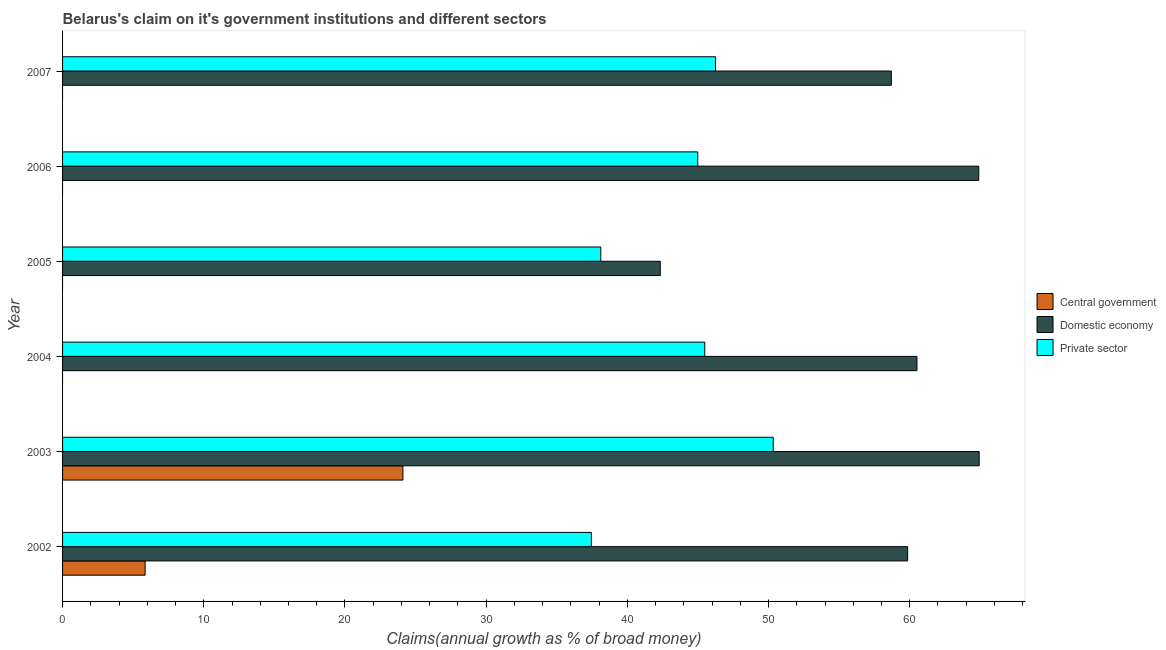How many different coloured bars are there?
Offer a very short reply. 3. How many groups of bars are there?
Your answer should be very brief. 6. Are the number of bars on each tick of the Y-axis equal?
Ensure brevity in your answer.  No. How many bars are there on the 4th tick from the top?
Make the answer very short. 2. How many bars are there on the 1st tick from the bottom?
Ensure brevity in your answer.  3. What is the label of the 3rd group of bars from the top?
Ensure brevity in your answer.  2005. In how many cases, is the number of bars for a given year not equal to the number of legend labels?
Ensure brevity in your answer.  4. What is the percentage of claim on the domestic economy in 2003?
Offer a terse response. 64.92. Across all years, what is the maximum percentage of claim on the domestic economy?
Your answer should be very brief. 64.92. Across all years, what is the minimum percentage of claim on the central government?
Offer a terse response. 0. What is the total percentage of claim on the private sector in the graph?
Offer a very short reply. 262.62. What is the difference between the percentage of claim on the private sector in 2005 and that in 2007?
Your response must be concise. -8.13. What is the difference between the percentage of claim on the domestic economy in 2004 and the percentage of claim on the central government in 2003?
Ensure brevity in your answer.  36.41. What is the average percentage of claim on the central government per year?
Your answer should be very brief. 4.99. In the year 2002, what is the difference between the percentage of claim on the central government and percentage of claim on the private sector?
Offer a very short reply. -31.6. In how many years, is the percentage of claim on the domestic economy greater than 38 %?
Provide a short and direct response. 6. What is the ratio of the percentage of claim on the domestic economy in 2002 to that in 2006?
Offer a very short reply. 0.92. Is the difference between the percentage of claim on the domestic economy in 2006 and 2007 greater than the difference between the percentage of claim on the private sector in 2006 and 2007?
Provide a succinct answer. Yes. What is the difference between the highest and the second highest percentage of claim on the domestic economy?
Ensure brevity in your answer.  0.03. What is the difference between the highest and the lowest percentage of claim on the private sector?
Your answer should be very brief. 12.88. In how many years, is the percentage of claim on the private sector greater than the average percentage of claim on the private sector taken over all years?
Make the answer very short. 4. Is the sum of the percentage of claim on the domestic economy in 2003 and 2006 greater than the maximum percentage of claim on the central government across all years?
Ensure brevity in your answer.  Yes. How many bars are there?
Offer a very short reply. 14. Are the values on the major ticks of X-axis written in scientific E-notation?
Give a very brief answer. No. Does the graph contain grids?
Give a very brief answer. No. Where does the legend appear in the graph?
Offer a very short reply. Center right. How many legend labels are there?
Provide a succinct answer. 3. What is the title of the graph?
Give a very brief answer. Belarus's claim on it's government institutions and different sectors. Does "Gaseous fuel" appear as one of the legend labels in the graph?
Your answer should be compact. No. What is the label or title of the X-axis?
Your response must be concise. Claims(annual growth as % of broad money). What is the Claims(annual growth as % of broad money) in Central government in 2002?
Provide a short and direct response. 5.85. What is the Claims(annual growth as % of broad money) in Domestic economy in 2002?
Your answer should be compact. 59.85. What is the Claims(annual growth as % of broad money) of Private sector in 2002?
Offer a terse response. 37.45. What is the Claims(annual growth as % of broad money) of Central government in 2003?
Provide a succinct answer. 24.1. What is the Claims(annual growth as % of broad money) of Domestic economy in 2003?
Give a very brief answer. 64.92. What is the Claims(annual growth as % of broad money) of Private sector in 2003?
Give a very brief answer. 50.33. What is the Claims(annual growth as % of broad money) of Central government in 2004?
Offer a terse response. 0. What is the Claims(annual growth as % of broad money) of Domestic economy in 2004?
Your answer should be compact. 60.51. What is the Claims(annual growth as % of broad money) in Private sector in 2004?
Your answer should be very brief. 45.48. What is the Claims(annual growth as % of broad money) in Central government in 2005?
Your answer should be compact. 0. What is the Claims(annual growth as % of broad money) in Domestic economy in 2005?
Offer a very short reply. 42.33. What is the Claims(annual growth as % of broad money) of Private sector in 2005?
Make the answer very short. 38.12. What is the Claims(annual growth as % of broad money) of Domestic economy in 2006?
Your answer should be compact. 64.89. What is the Claims(annual growth as % of broad money) in Private sector in 2006?
Provide a succinct answer. 44.99. What is the Claims(annual growth as % of broad money) in Domestic economy in 2007?
Provide a succinct answer. 58.7. What is the Claims(annual growth as % of broad money) in Private sector in 2007?
Offer a very short reply. 46.24. Across all years, what is the maximum Claims(annual growth as % of broad money) of Central government?
Offer a terse response. 24.1. Across all years, what is the maximum Claims(annual growth as % of broad money) in Domestic economy?
Ensure brevity in your answer.  64.92. Across all years, what is the maximum Claims(annual growth as % of broad money) in Private sector?
Your answer should be very brief. 50.33. Across all years, what is the minimum Claims(annual growth as % of broad money) in Domestic economy?
Provide a succinct answer. 42.33. Across all years, what is the minimum Claims(annual growth as % of broad money) in Private sector?
Provide a succinct answer. 37.45. What is the total Claims(annual growth as % of broad money) in Central government in the graph?
Your answer should be compact. 29.95. What is the total Claims(annual growth as % of broad money) in Domestic economy in the graph?
Keep it short and to the point. 351.2. What is the total Claims(annual growth as % of broad money) in Private sector in the graph?
Make the answer very short. 262.62. What is the difference between the Claims(annual growth as % of broad money) of Central government in 2002 and that in 2003?
Give a very brief answer. -18.26. What is the difference between the Claims(annual growth as % of broad money) of Domestic economy in 2002 and that in 2003?
Ensure brevity in your answer.  -5.07. What is the difference between the Claims(annual growth as % of broad money) in Private sector in 2002 and that in 2003?
Your response must be concise. -12.88. What is the difference between the Claims(annual growth as % of broad money) in Domestic economy in 2002 and that in 2004?
Provide a short and direct response. -0.66. What is the difference between the Claims(annual growth as % of broad money) of Private sector in 2002 and that in 2004?
Your answer should be very brief. -8.03. What is the difference between the Claims(annual growth as % of broad money) in Domestic economy in 2002 and that in 2005?
Make the answer very short. 17.52. What is the difference between the Claims(annual growth as % of broad money) of Private sector in 2002 and that in 2005?
Your answer should be compact. -0.67. What is the difference between the Claims(annual growth as % of broad money) in Domestic economy in 2002 and that in 2006?
Ensure brevity in your answer.  -5.04. What is the difference between the Claims(annual growth as % of broad money) of Private sector in 2002 and that in 2006?
Your answer should be compact. -7.54. What is the difference between the Claims(annual growth as % of broad money) in Domestic economy in 2002 and that in 2007?
Your answer should be very brief. 1.15. What is the difference between the Claims(annual growth as % of broad money) in Private sector in 2002 and that in 2007?
Make the answer very short. -8.79. What is the difference between the Claims(annual growth as % of broad money) of Domestic economy in 2003 and that in 2004?
Your answer should be compact. 4.41. What is the difference between the Claims(annual growth as % of broad money) in Private sector in 2003 and that in 2004?
Ensure brevity in your answer.  4.85. What is the difference between the Claims(annual growth as % of broad money) in Domestic economy in 2003 and that in 2005?
Your response must be concise. 22.59. What is the difference between the Claims(annual growth as % of broad money) of Private sector in 2003 and that in 2005?
Your response must be concise. 12.22. What is the difference between the Claims(annual growth as % of broad money) in Domestic economy in 2003 and that in 2006?
Give a very brief answer. 0.03. What is the difference between the Claims(annual growth as % of broad money) of Private sector in 2003 and that in 2006?
Your answer should be compact. 5.35. What is the difference between the Claims(annual growth as % of broad money) in Domestic economy in 2003 and that in 2007?
Your answer should be very brief. 6.22. What is the difference between the Claims(annual growth as % of broad money) in Private sector in 2003 and that in 2007?
Your response must be concise. 4.09. What is the difference between the Claims(annual growth as % of broad money) of Domestic economy in 2004 and that in 2005?
Ensure brevity in your answer.  18.18. What is the difference between the Claims(annual growth as % of broad money) of Private sector in 2004 and that in 2005?
Your answer should be very brief. 7.37. What is the difference between the Claims(annual growth as % of broad money) in Domestic economy in 2004 and that in 2006?
Offer a terse response. -4.38. What is the difference between the Claims(annual growth as % of broad money) in Private sector in 2004 and that in 2006?
Make the answer very short. 0.5. What is the difference between the Claims(annual growth as % of broad money) of Domestic economy in 2004 and that in 2007?
Provide a short and direct response. 1.81. What is the difference between the Claims(annual growth as % of broad money) of Private sector in 2004 and that in 2007?
Give a very brief answer. -0.76. What is the difference between the Claims(annual growth as % of broad money) of Domestic economy in 2005 and that in 2006?
Ensure brevity in your answer.  -22.56. What is the difference between the Claims(annual growth as % of broad money) in Private sector in 2005 and that in 2006?
Your answer should be very brief. -6.87. What is the difference between the Claims(annual growth as % of broad money) of Domestic economy in 2005 and that in 2007?
Provide a short and direct response. -16.37. What is the difference between the Claims(annual growth as % of broad money) in Private sector in 2005 and that in 2007?
Ensure brevity in your answer.  -8.13. What is the difference between the Claims(annual growth as % of broad money) of Domestic economy in 2006 and that in 2007?
Give a very brief answer. 6.19. What is the difference between the Claims(annual growth as % of broad money) of Private sector in 2006 and that in 2007?
Provide a short and direct response. -1.26. What is the difference between the Claims(annual growth as % of broad money) in Central government in 2002 and the Claims(annual growth as % of broad money) in Domestic economy in 2003?
Give a very brief answer. -59.07. What is the difference between the Claims(annual growth as % of broad money) of Central government in 2002 and the Claims(annual growth as % of broad money) of Private sector in 2003?
Your answer should be compact. -44.49. What is the difference between the Claims(annual growth as % of broad money) of Domestic economy in 2002 and the Claims(annual growth as % of broad money) of Private sector in 2003?
Provide a short and direct response. 9.52. What is the difference between the Claims(annual growth as % of broad money) in Central government in 2002 and the Claims(annual growth as % of broad money) in Domestic economy in 2004?
Offer a very short reply. -54.66. What is the difference between the Claims(annual growth as % of broad money) of Central government in 2002 and the Claims(annual growth as % of broad money) of Private sector in 2004?
Offer a very short reply. -39.64. What is the difference between the Claims(annual growth as % of broad money) of Domestic economy in 2002 and the Claims(annual growth as % of broad money) of Private sector in 2004?
Offer a very short reply. 14.37. What is the difference between the Claims(annual growth as % of broad money) in Central government in 2002 and the Claims(annual growth as % of broad money) in Domestic economy in 2005?
Keep it short and to the point. -36.48. What is the difference between the Claims(annual growth as % of broad money) in Central government in 2002 and the Claims(annual growth as % of broad money) in Private sector in 2005?
Give a very brief answer. -32.27. What is the difference between the Claims(annual growth as % of broad money) of Domestic economy in 2002 and the Claims(annual growth as % of broad money) of Private sector in 2005?
Make the answer very short. 21.73. What is the difference between the Claims(annual growth as % of broad money) of Central government in 2002 and the Claims(annual growth as % of broad money) of Domestic economy in 2006?
Give a very brief answer. -59.04. What is the difference between the Claims(annual growth as % of broad money) of Central government in 2002 and the Claims(annual growth as % of broad money) of Private sector in 2006?
Your answer should be very brief. -39.14. What is the difference between the Claims(annual growth as % of broad money) of Domestic economy in 2002 and the Claims(annual growth as % of broad money) of Private sector in 2006?
Offer a terse response. 14.86. What is the difference between the Claims(annual growth as % of broad money) of Central government in 2002 and the Claims(annual growth as % of broad money) of Domestic economy in 2007?
Give a very brief answer. -52.85. What is the difference between the Claims(annual growth as % of broad money) of Central government in 2002 and the Claims(annual growth as % of broad money) of Private sector in 2007?
Make the answer very short. -40.4. What is the difference between the Claims(annual growth as % of broad money) of Domestic economy in 2002 and the Claims(annual growth as % of broad money) of Private sector in 2007?
Ensure brevity in your answer.  13.61. What is the difference between the Claims(annual growth as % of broad money) in Central government in 2003 and the Claims(annual growth as % of broad money) in Domestic economy in 2004?
Your response must be concise. -36.41. What is the difference between the Claims(annual growth as % of broad money) in Central government in 2003 and the Claims(annual growth as % of broad money) in Private sector in 2004?
Offer a terse response. -21.38. What is the difference between the Claims(annual growth as % of broad money) of Domestic economy in 2003 and the Claims(annual growth as % of broad money) of Private sector in 2004?
Make the answer very short. 19.44. What is the difference between the Claims(annual growth as % of broad money) of Central government in 2003 and the Claims(annual growth as % of broad money) of Domestic economy in 2005?
Provide a succinct answer. -18.23. What is the difference between the Claims(annual growth as % of broad money) of Central government in 2003 and the Claims(annual growth as % of broad money) of Private sector in 2005?
Offer a very short reply. -14.01. What is the difference between the Claims(annual growth as % of broad money) in Domestic economy in 2003 and the Claims(annual growth as % of broad money) in Private sector in 2005?
Your response must be concise. 26.8. What is the difference between the Claims(annual growth as % of broad money) of Central government in 2003 and the Claims(annual growth as % of broad money) of Domestic economy in 2006?
Your answer should be compact. -40.79. What is the difference between the Claims(annual growth as % of broad money) of Central government in 2003 and the Claims(annual growth as % of broad money) of Private sector in 2006?
Offer a very short reply. -20.88. What is the difference between the Claims(annual growth as % of broad money) in Domestic economy in 2003 and the Claims(annual growth as % of broad money) in Private sector in 2006?
Provide a short and direct response. 19.93. What is the difference between the Claims(annual growth as % of broad money) in Central government in 2003 and the Claims(annual growth as % of broad money) in Domestic economy in 2007?
Ensure brevity in your answer.  -34.59. What is the difference between the Claims(annual growth as % of broad money) in Central government in 2003 and the Claims(annual growth as % of broad money) in Private sector in 2007?
Your response must be concise. -22.14. What is the difference between the Claims(annual growth as % of broad money) of Domestic economy in 2003 and the Claims(annual growth as % of broad money) of Private sector in 2007?
Your answer should be very brief. 18.68. What is the difference between the Claims(annual growth as % of broad money) in Domestic economy in 2004 and the Claims(annual growth as % of broad money) in Private sector in 2005?
Provide a succinct answer. 22.39. What is the difference between the Claims(annual growth as % of broad money) of Domestic economy in 2004 and the Claims(annual growth as % of broad money) of Private sector in 2006?
Offer a very short reply. 15.53. What is the difference between the Claims(annual growth as % of broad money) in Domestic economy in 2004 and the Claims(annual growth as % of broad money) in Private sector in 2007?
Keep it short and to the point. 14.27. What is the difference between the Claims(annual growth as % of broad money) in Domestic economy in 2005 and the Claims(annual growth as % of broad money) in Private sector in 2006?
Provide a short and direct response. -2.66. What is the difference between the Claims(annual growth as % of broad money) of Domestic economy in 2005 and the Claims(annual growth as % of broad money) of Private sector in 2007?
Your response must be concise. -3.91. What is the difference between the Claims(annual growth as % of broad money) in Domestic economy in 2006 and the Claims(annual growth as % of broad money) in Private sector in 2007?
Your answer should be compact. 18.65. What is the average Claims(annual growth as % of broad money) of Central government per year?
Your answer should be very brief. 4.99. What is the average Claims(annual growth as % of broad money) in Domestic economy per year?
Give a very brief answer. 58.53. What is the average Claims(annual growth as % of broad money) in Private sector per year?
Provide a short and direct response. 43.77. In the year 2002, what is the difference between the Claims(annual growth as % of broad money) in Central government and Claims(annual growth as % of broad money) in Domestic economy?
Your response must be concise. -54. In the year 2002, what is the difference between the Claims(annual growth as % of broad money) in Central government and Claims(annual growth as % of broad money) in Private sector?
Provide a succinct answer. -31.6. In the year 2002, what is the difference between the Claims(annual growth as % of broad money) in Domestic economy and Claims(annual growth as % of broad money) in Private sector?
Offer a very short reply. 22.4. In the year 2003, what is the difference between the Claims(annual growth as % of broad money) of Central government and Claims(annual growth as % of broad money) of Domestic economy?
Your answer should be very brief. -40.82. In the year 2003, what is the difference between the Claims(annual growth as % of broad money) of Central government and Claims(annual growth as % of broad money) of Private sector?
Your answer should be very brief. -26.23. In the year 2003, what is the difference between the Claims(annual growth as % of broad money) in Domestic economy and Claims(annual growth as % of broad money) in Private sector?
Provide a succinct answer. 14.59. In the year 2004, what is the difference between the Claims(annual growth as % of broad money) of Domestic economy and Claims(annual growth as % of broad money) of Private sector?
Your answer should be compact. 15.03. In the year 2005, what is the difference between the Claims(annual growth as % of broad money) of Domestic economy and Claims(annual growth as % of broad money) of Private sector?
Keep it short and to the point. 4.21. In the year 2006, what is the difference between the Claims(annual growth as % of broad money) in Domestic economy and Claims(annual growth as % of broad money) in Private sector?
Make the answer very short. 19.9. In the year 2007, what is the difference between the Claims(annual growth as % of broad money) in Domestic economy and Claims(annual growth as % of broad money) in Private sector?
Your answer should be very brief. 12.45. What is the ratio of the Claims(annual growth as % of broad money) in Central government in 2002 to that in 2003?
Your answer should be very brief. 0.24. What is the ratio of the Claims(annual growth as % of broad money) of Domestic economy in 2002 to that in 2003?
Ensure brevity in your answer.  0.92. What is the ratio of the Claims(annual growth as % of broad money) in Private sector in 2002 to that in 2003?
Keep it short and to the point. 0.74. What is the ratio of the Claims(annual growth as % of broad money) of Domestic economy in 2002 to that in 2004?
Offer a terse response. 0.99. What is the ratio of the Claims(annual growth as % of broad money) of Private sector in 2002 to that in 2004?
Your answer should be very brief. 0.82. What is the ratio of the Claims(annual growth as % of broad money) of Domestic economy in 2002 to that in 2005?
Your answer should be compact. 1.41. What is the ratio of the Claims(annual growth as % of broad money) in Private sector in 2002 to that in 2005?
Provide a succinct answer. 0.98. What is the ratio of the Claims(annual growth as % of broad money) of Domestic economy in 2002 to that in 2006?
Make the answer very short. 0.92. What is the ratio of the Claims(annual growth as % of broad money) of Private sector in 2002 to that in 2006?
Make the answer very short. 0.83. What is the ratio of the Claims(annual growth as % of broad money) of Domestic economy in 2002 to that in 2007?
Your answer should be very brief. 1.02. What is the ratio of the Claims(annual growth as % of broad money) of Private sector in 2002 to that in 2007?
Your response must be concise. 0.81. What is the ratio of the Claims(annual growth as % of broad money) of Domestic economy in 2003 to that in 2004?
Give a very brief answer. 1.07. What is the ratio of the Claims(annual growth as % of broad money) in Private sector in 2003 to that in 2004?
Your answer should be compact. 1.11. What is the ratio of the Claims(annual growth as % of broad money) of Domestic economy in 2003 to that in 2005?
Offer a terse response. 1.53. What is the ratio of the Claims(annual growth as % of broad money) in Private sector in 2003 to that in 2005?
Keep it short and to the point. 1.32. What is the ratio of the Claims(annual growth as % of broad money) of Domestic economy in 2003 to that in 2006?
Make the answer very short. 1. What is the ratio of the Claims(annual growth as % of broad money) in Private sector in 2003 to that in 2006?
Ensure brevity in your answer.  1.12. What is the ratio of the Claims(annual growth as % of broad money) of Domestic economy in 2003 to that in 2007?
Keep it short and to the point. 1.11. What is the ratio of the Claims(annual growth as % of broad money) in Private sector in 2003 to that in 2007?
Ensure brevity in your answer.  1.09. What is the ratio of the Claims(annual growth as % of broad money) in Domestic economy in 2004 to that in 2005?
Offer a very short reply. 1.43. What is the ratio of the Claims(annual growth as % of broad money) of Private sector in 2004 to that in 2005?
Your response must be concise. 1.19. What is the ratio of the Claims(annual growth as % of broad money) of Domestic economy in 2004 to that in 2006?
Make the answer very short. 0.93. What is the ratio of the Claims(annual growth as % of broad money) of Private sector in 2004 to that in 2006?
Your response must be concise. 1.01. What is the ratio of the Claims(annual growth as % of broad money) of Domestic economy in 2004 to that in 2007?
Provide a succinct answer. 1.03. What is the ratio of the Claims(annual growth as % of broad money) in Private sector in 2004 to that in 2007?
Provide a succinct answer. 0.98. What is the ratio of the Claims(annual growth as % of broad money) in Domestic economy in 2005 to that in 2006?
Offer a very short reply. 0.65. What is the ratio of the Claims(annual growth as % of broad money) in Private sector in 2005 to that in 2006?
Your response must be concise. 0.85. What is the ratio of the Claims(annual growth as % of broad money) in Domestic economy in 2005 to that in 2007?
Make the answer very short. 0.72. What is the ratio of the Claims(annual growth as % of broad money) in Private sector in 2005 to that in 2007?
Keep it short and to the point. 0.82. What is the ratio of the Claims(annual growth as % of broad money) in Domestic economy in 2006 to that in 2007?
Make the answer very short. 1.11. What is the ratio of the Claims(annual growth as % of broad money) in Private sector in 2006 to that in 2007?
Offer a terse response. 0.97. What is the difference between the highest and the second highest Claims(annual growth as % of broad money) of Domestic economy?
Offer a terse response. 0.03. What is the difference between the highest and the second highest Claims(annual growth as % of broad money) in Private sector?
Give a very brief answer. 4.09. What is the difference between the highest and the lowest Claims(annual growth as % of broad money) in Central government?
Ensure brevity in your answer.  24.1. What is the difference between the highest and the lowest Claims(annual growth as % of broad money) of Domestic economy?
Give a very brief answer. 22.59. What is the difference between the highest and the lowest Claims(annual growth as % of broad money) of Private sector?
Your answer should be compact. 12.88. 